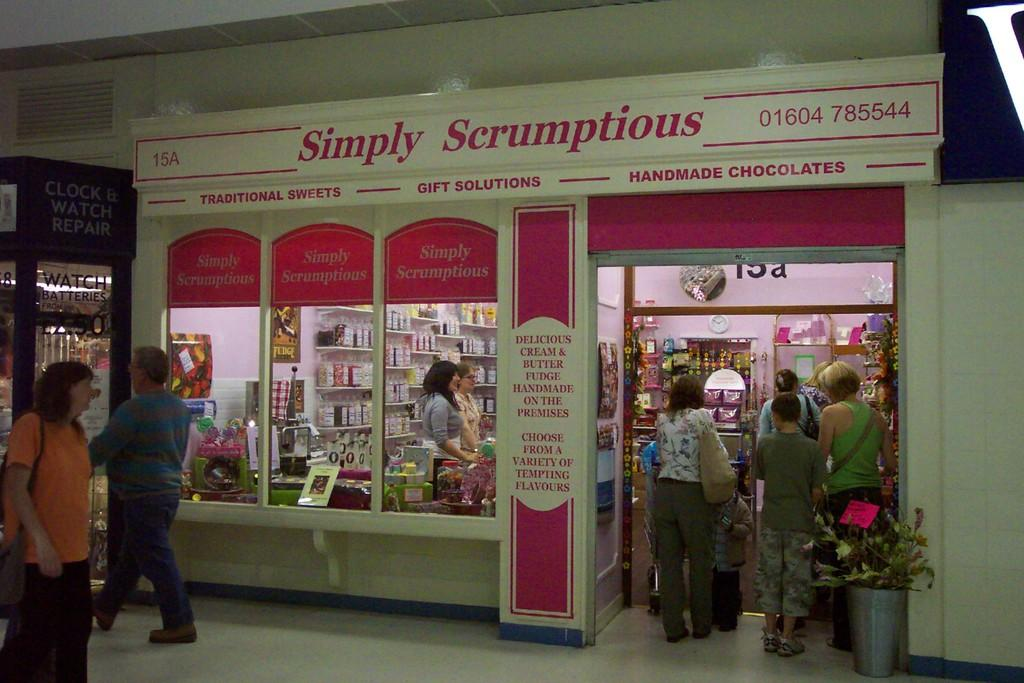How many people are present in the image? There are many people in the image. What are the people wearing? The people are wearing clothes. What type of establishment can be seen in the image? There is a shop in the image. What is the surface that the people and shop are standing on? There is a floor visible in the image. What type of decorative item is present in the image? There is a plant pot in the image. What type of request is being made by the shelf in the image? There is no shelf present in the image, so it cannot make any requests. 